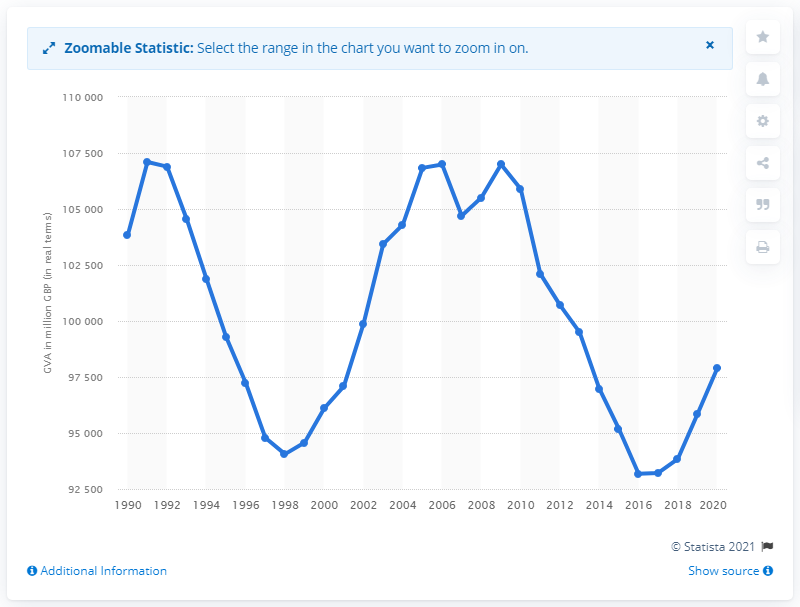List a handful of essential elements in this visual. The highest GVA for the public administration and defense sector was recorded in 1991. The gross value added of the public administration and defense sector in 2020 was approximately 97,823. 